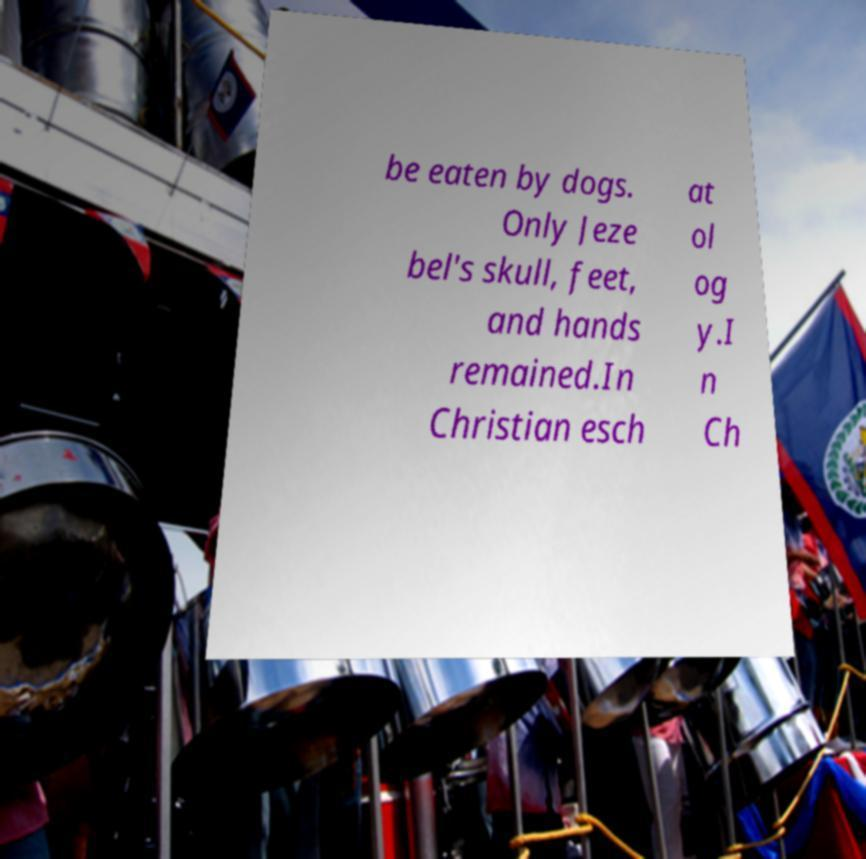Please read and relay the text visible in this image. What does it say? be eaten by dogs. Only Jeze bel's skull, feet, and hands remained.In Christian esch at ol og y.I n Ch 